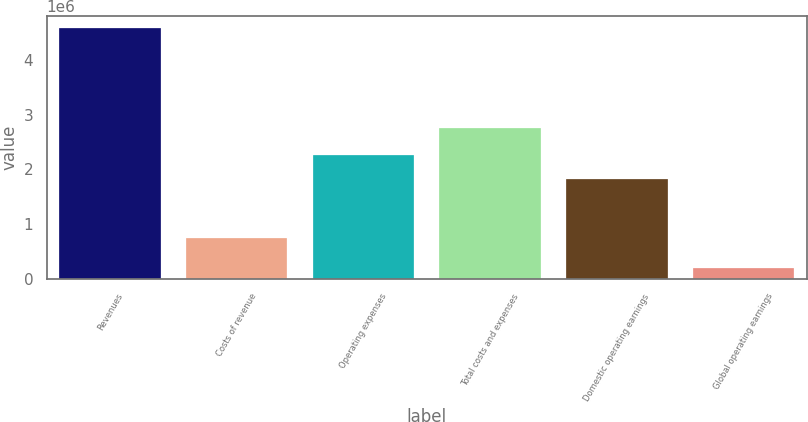Convert chart to OTSL. <chart><loc_0><loc_0><loc_500><loc_500><bar_chart><fcel>Revenues<fcel>Costs of revenue<fcel>Operating expenses<fcel>Total costs and expenses<fcel>Domestic operating earnings<fcel>Global operating earnings<nl><fcel>4.57517e+06<fcel>755729<fcel>2.25796e+06<fcel>2.75427e+06<fcel>1.8209e+06<fcel>204543<nl></chart> 